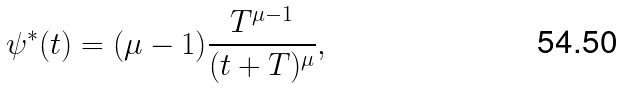Convert formula to latex. <formula><loc_0><loc_0><loc_500><loc_500>\psi ^ { * } ( t ) = ( \mu - 1 ) \frac { T ^ { \mu - 1 } } { ( t + T ) ^ { \mu } } ,</formula> 